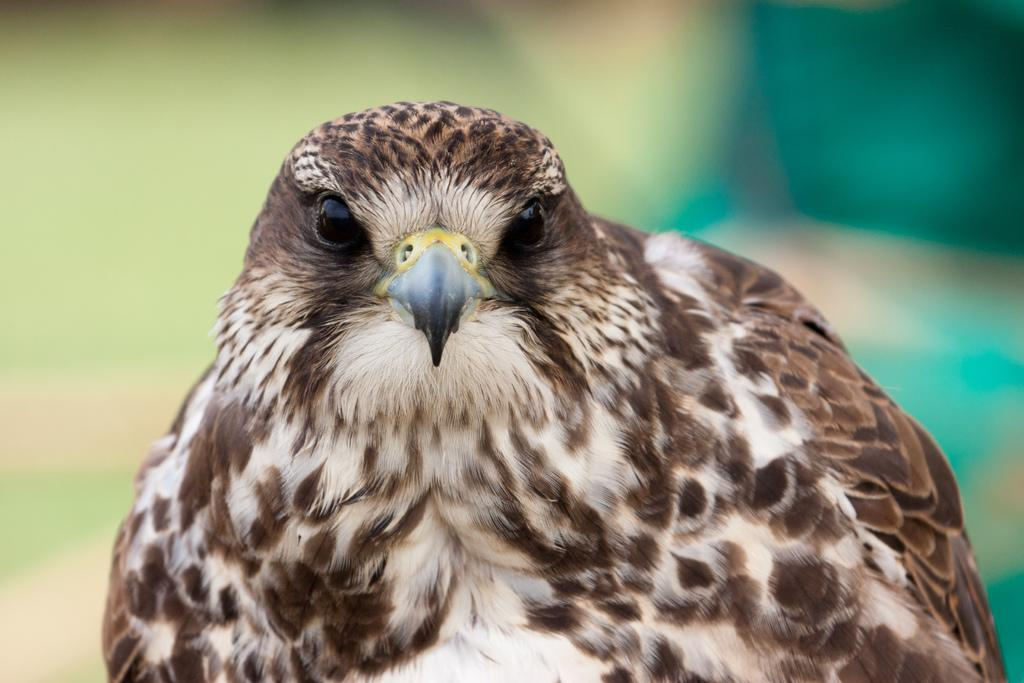What type of animal is in the image? The image contains a hawk. Can you describe the color of the hawk? The hawk is in brown and white color. Who is the owner of the steam in the image? There is no steam present in the image, and therefore no owner can be identified. 